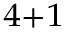Convert formula to latex. <formula><loc_0><loc_0><loc_500><loc_500>_ { 4 + 1 }</formula> 